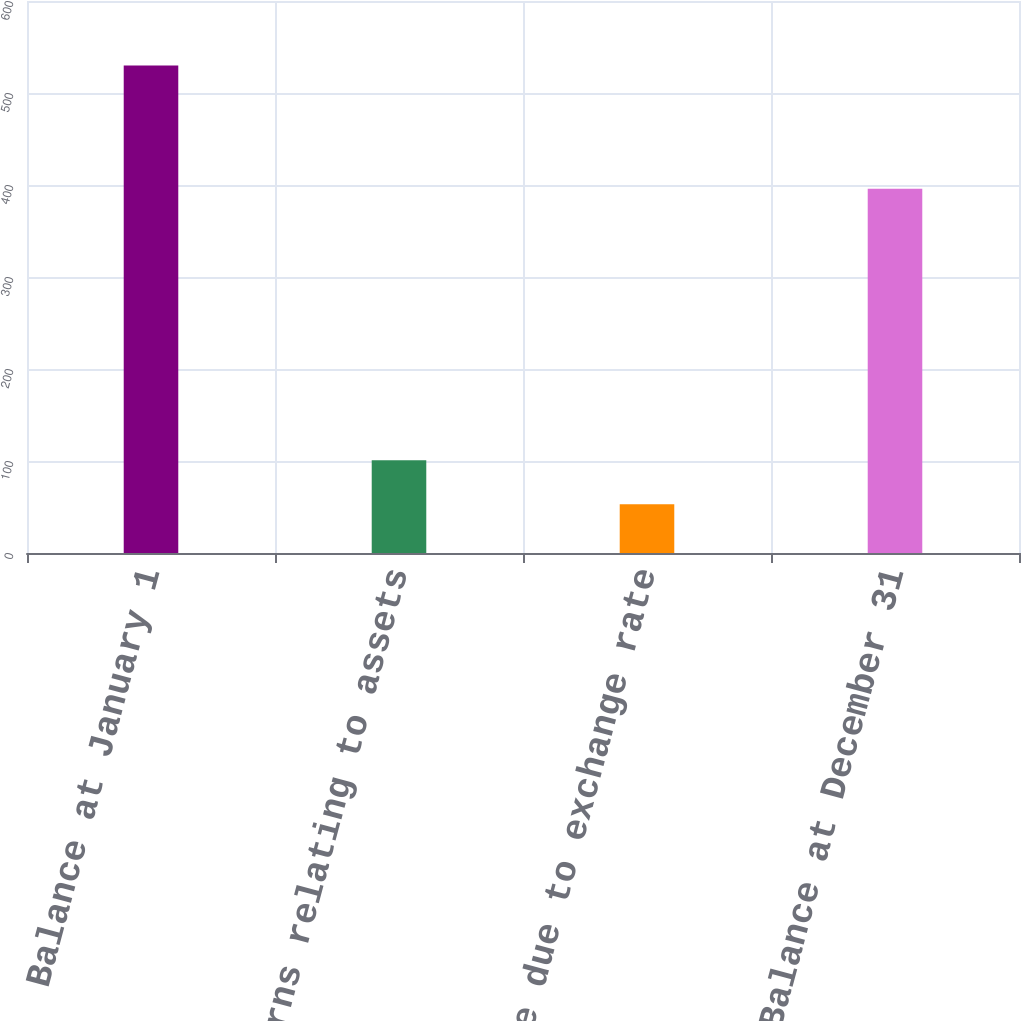<chart> <loc_0><loc_0><loc_500><loc_500><bar_chart><fcel>Balance at January 1<fcel>Returns relating to assets<fcel>Change due to exchange rate<fcel>Balance at December 31<nl><fcel>530<fcel>100.7<fcel>53<fcel>396<nl></chart> 